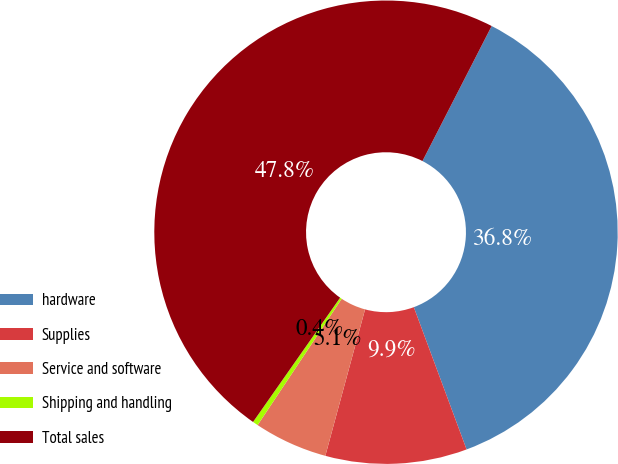Convert chart. <chart><loc_0><loc_0><loc_500><loc_500><pie_chart><fcel>hardware<fcel>Supplies<fcel>Service and software<fcel>Shipping and handling<fcel>Total sales<nl><fcel>36.81%<fcel>9.87%<fcel>5.13%<fcel>0.38%<fcel>47.81%<nl></chart> 